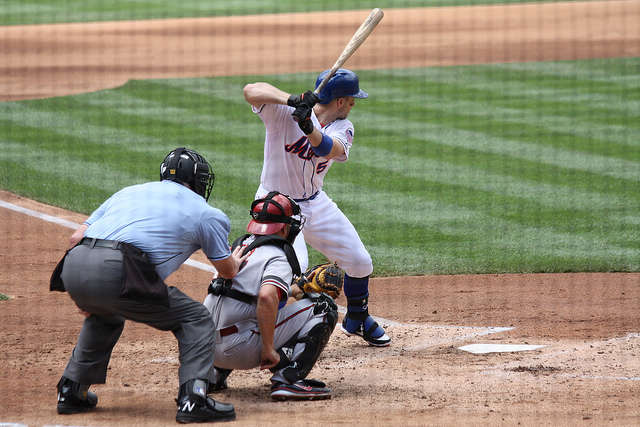Identify the text displayed in this image. 5 N 